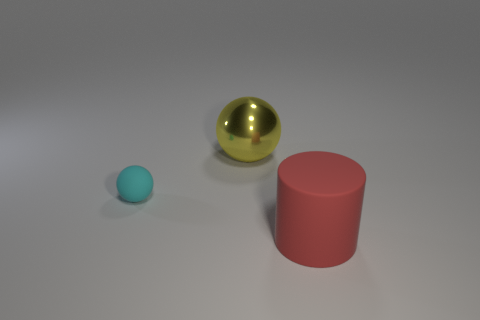Add 2 small balls. How many objects exist? 5 Subtract all cylinders. How many objects are left? 2 Subtract all big red matte things. Subtract all blue metal things. How many objects are left? 2 Add 1 metal balls. How many metal balls are left? 2 Add 3 big blue matte blocks. How many big blue matte blocks exist? 3 Subtract 0 gray cylinders. How many objects are left? 3 